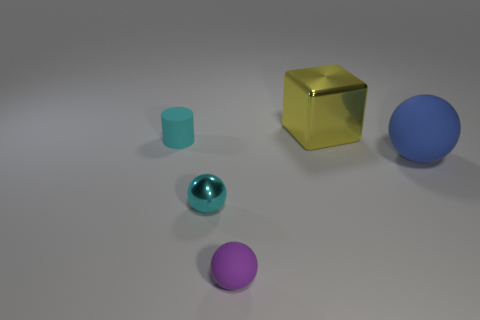Add 1 matte things. How many objects exist? 6 Subtract all blocks. How many objects are left? 4 Subtract 1 yellow blocks. How many objects are left? 4 Subtract all large green rubber cubes. Subtract all cyan matte cylinders. How many objects are left? 4 Add 1 yellow metallic objects. How many yellow metallic objects are left? 2 Add 1 small red shiny objects. How many small red shiny objects exist? 1 